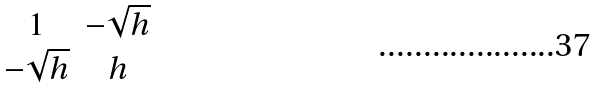<formula> <loc_0><loc_0><loc_500><loc_500>\begin{matrix} 1 & - \sqrt { h } \\ - \sqrt { h } & h \end{matrix}</formula> 